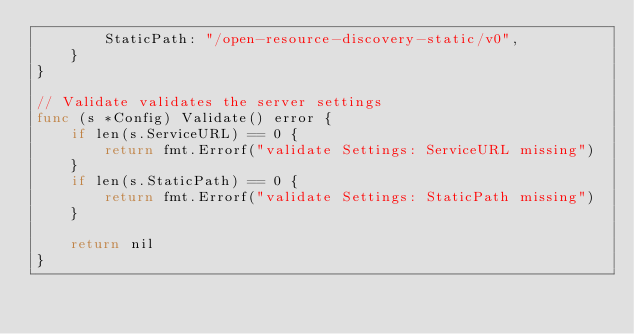<code> <loc_0><loc_0><loc_500><loc_500><_Go_>		StaticPath: "/open-resource-discovery-static/v0",
	}
}

// Validate validates the server settings
func (s *Config) Validate() error {
	if len(s.ServiceURL) == 0 {
		return fmt.Errorf("validate Settings: ServiceURL missing")
	}
	if len(s.StaticPath) == 0 {
		return fmt.Errorf("validate Settings: StaticPath missing")
	}

	return nil
}
</code> 